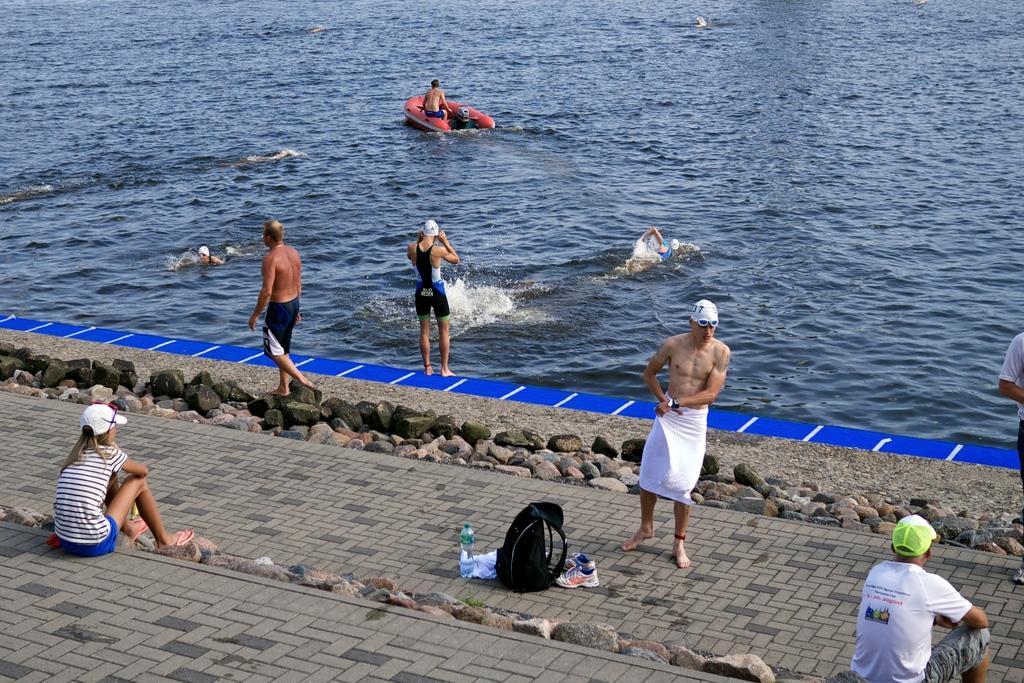In one or two sentences, can you explain what this image depicts? In this image, we can see persons wearing clothes. There is person on the boat which is floating on the water. There is a bag, shoes and bottle at the bottom of the image. 